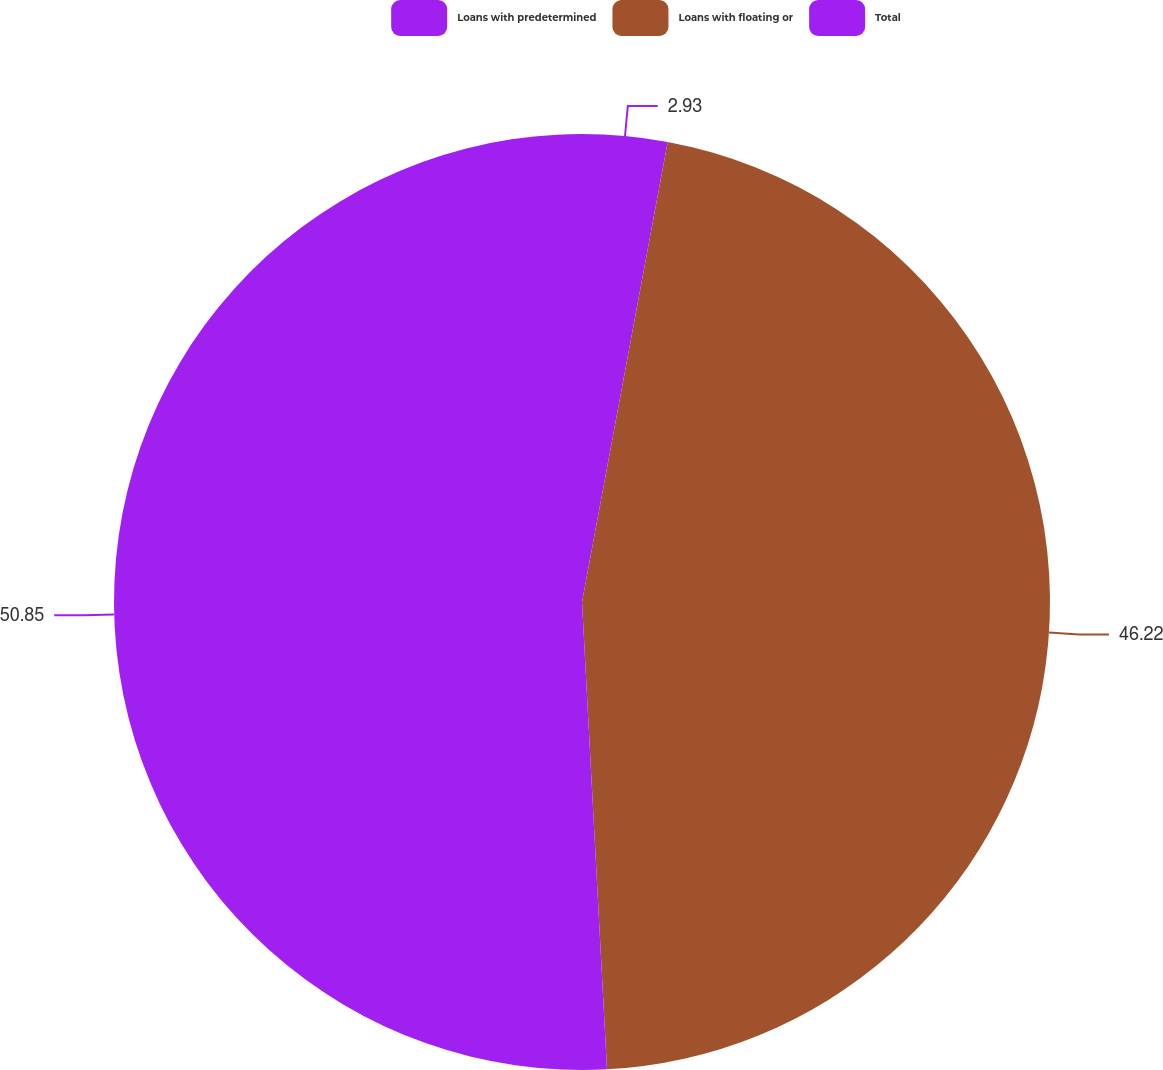Convert chart. <chart><loc_0><loc_0><loc_500><loc_500><pie_chart><fcel>Loans with predetermined<fcel>Loans with floating or<fcel>Total<nl><fcel>2.93%<fcel>46.22%<fcel>50.85%<nl></chart> 